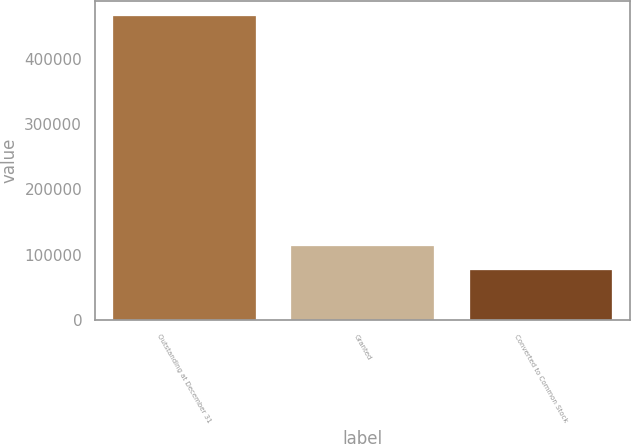Convert chart. <chart><loc_0><loc_0><loc_500><loc_500><bar_chart><fcel>Outstanding at December 31<fcel>Granted<fcel>Converted to Common Stock<nl><fcel>465340<fcel>113813<fcel>76051<nl></chart> 